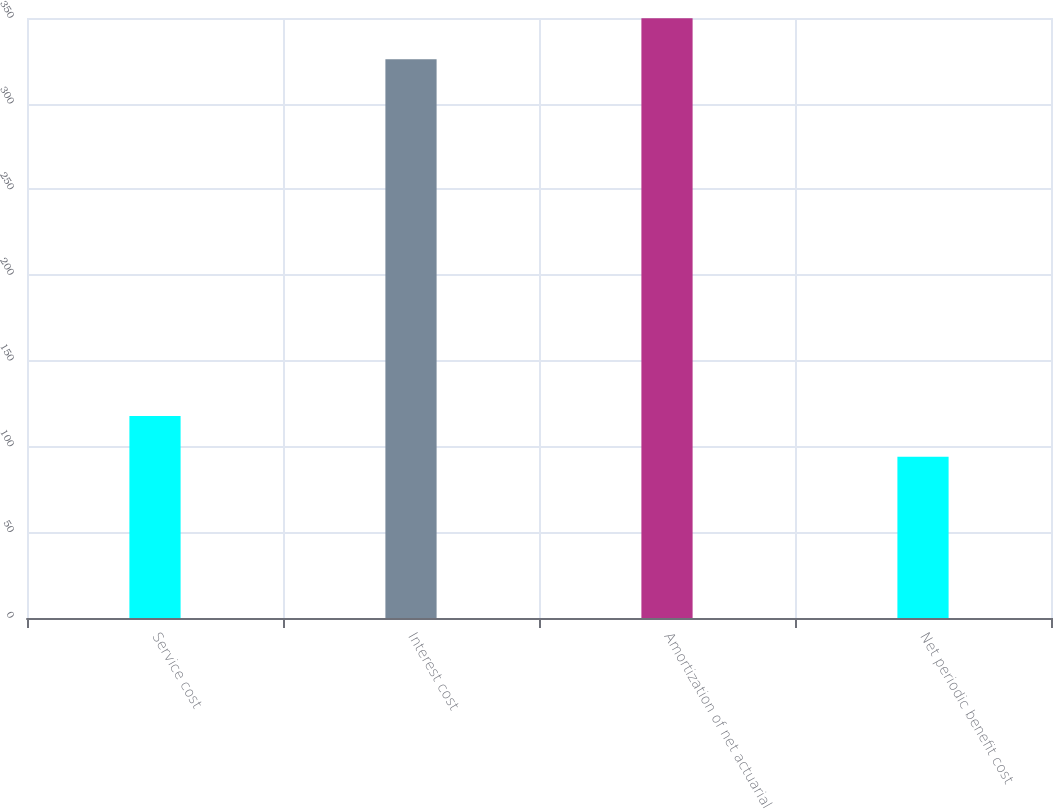Convert chart to OTSL. <chart><loc_0><loc_0><loc_500><loc_500><bar_chart><fcel>Service cost<fcel>Interest cost<fcel>Amortization of net actuarial<fcel>Net periodic benefit cost<nl><fcel>117.9<fcel>326<fcel>349.9<fcel>94<nl></chart> 